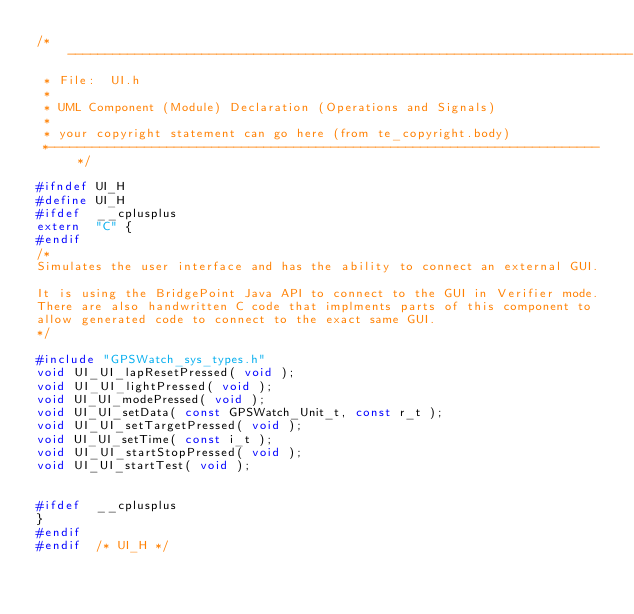<code> <loc_0><loc_0><loc_500><loc_500><_C_>/*----------------------------------------------------------------------------
 * File:  UI.h
 *
 * UML Component (Module) Declaration (Operations and Signals)
 *
 * your copyright statement can go here (from te_copyright.body)
 *--------------------------------------------------------------------------*/

#ifndef UI_H
#define UI_H
#ifdef	__cplusplus
extern	"C"	{
#endif
/*
Simulates the user interface and has the ability to connect an external GUI.

It is using the BridgePoint Java API to connect to the GUI in Verifier mode.
There are also handwritten C code that implments parts of this component to 
allow generated code to connect to the exact same GUI.
*/

#include "GPSWatch_sys_types.h"
void UI_UI_lapResetPressed( void );
void UI_UI_lightPressed( void );
void UI_UI_modePressed( void );
void UI_UI_setData( const GPSWatch_Unit_t, const r_t );
void UI_UI_setTargetPressed( void );
void UI_UI_setTime( const i_t );
void UI_UI_startStopPressed( void );
void UI_UI_startTest( void );


#ifdef	__cplusplus
}
#endif
#endif  /* UI_H */
</code> 